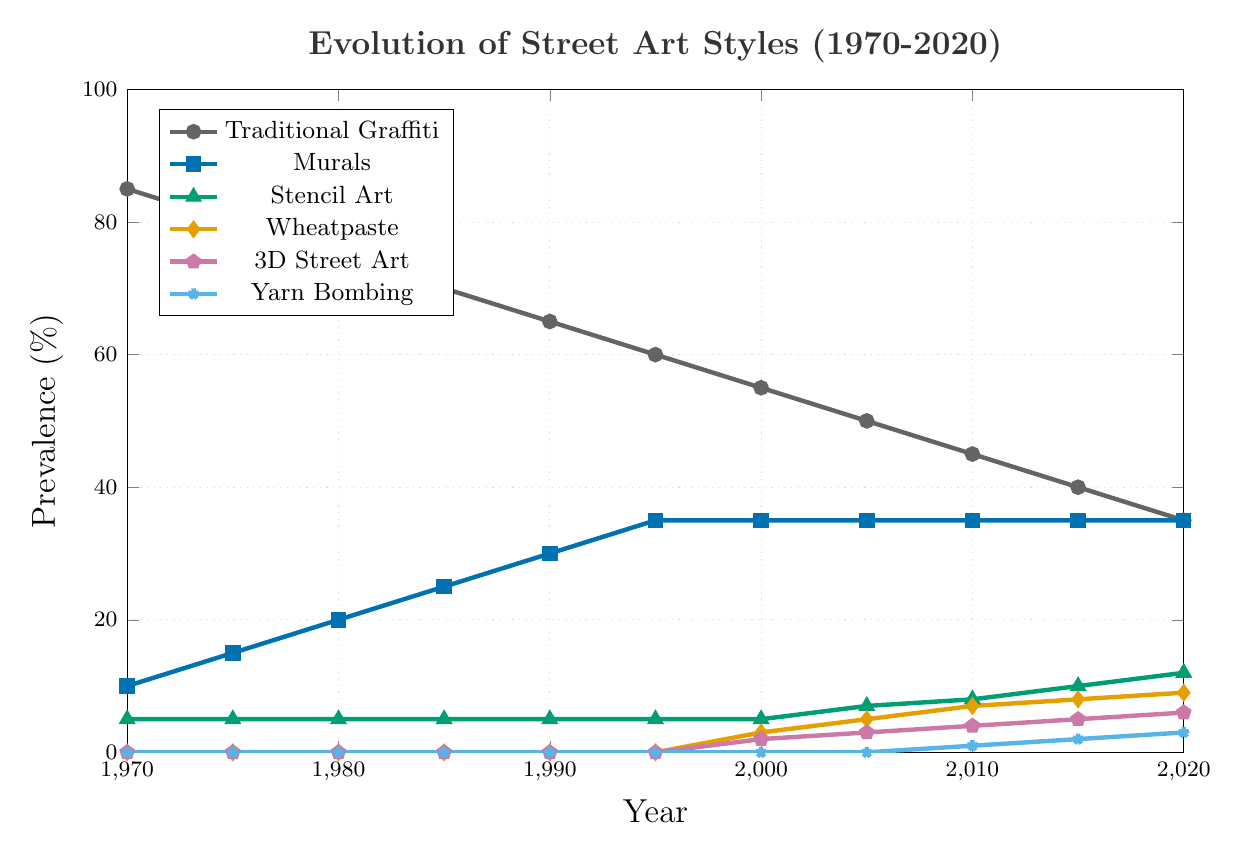What's the most prevalent street art style in 1970? Look at the figure and identify the highest value at the year 1970. Traditional Graffiti has the highest percentage at 85%.
Answer: Traditional Graffiti By how much did the prevalence of Traditional Graffiti decrease from 1970 to 2020? To find the decrement, subtract the value in 2020 from the value in 1970. It is 85% - 35% = 50%.
Answer: 50% Which art style saw its introduction after 1990 and gradually increased every subsequent decade? Search for the styles that have 0% prevalence until after 1990 and then start to rise. Wheatpaste, 3D Street Art, and Yarn Bombing fit this description.
Answer: Wheatpaste, 3D Street Art, Yarn Bombing What's the combined prevalence of Murals and Stencil Art in 2020? Add the prevalence percentages of Murals and Stencil Art in 2020. It's 35% (Murals) + 12% (Stencil Art)= 47%.
Answer: 47% Between 2000 and 2020, which art style had the steepest increase in prevalence? Calculate the difference for each art style from 2000 to 2020 and compare. Wheatpaste increased from 3% to 9%, an increase of 6%, which is the steepest among all styles.
Answer: Wheatpaste Which year did Murals reach a 35% prevalence and maintain it consistently? Look for the first year Murals reached 35% and check if it remains constant. It started in 1995 and stayed consistent afterward.
Answer: 1995 Compare the prevalence of Stencil Art in 1970 and 2020. Did it increase or decrease, and by how much? Subtract the value in 1970 from the value in 2020 for Stencil Art. It’s 12% (2020) - 5% (1970) = 7% increase.
Answer: Increase by 7% In what decade did 3D Street Art first appear and how much did it increase from its introduction up until 2020? 3D Street Art first appeared in 2000 at 2%. By 2020, it increased to 6%. Subtracting gives 6% - 2% = 4%.
Answer: 2000s, 4% How does the prevalence of Yarn Bombing in 2020 compare to that in 2010? Subtract the value in 2010 from the value in 2020 for Yarn Bombing. It’s 3% (2020) - 1% (2010) = 2% increase.
Answer: Increase by 2% What's the difference in prevalence between Traditional Graffiti and Murals in 2020? Subtract the prevalence of Murals from Traditional Graffiti in 2020. It's 35% (Traditional Graffiti) - 35% (Murals) = 0%.
Answer: 0% 